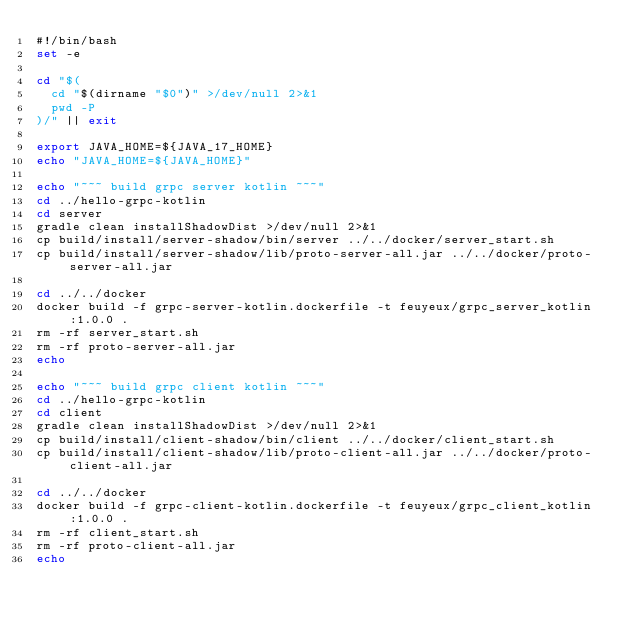Convert code to text. <code><loc_0><loc_0><loc_500><loc_500><_Bash_>#!/bin/bash
set -e

cd "$(
  cd "$(dirname "$0")" >/dev/null 2>&1
  pwd -P
)/" || exit

export JAVA_HOME=${JAVA_17_HOME}
echo "JAVA_HOME=${JAVA_HOME}"

echo "~~~ build grpc server kotlin ~~~"
cd ../hello-grpc-kotlin
cd server
gradle clean installShadowDist >/dev/null 2>&1
cp build/install/server-shadow/bin/server ../../docker/server_start.sh
cp build/install/server-shadow/lib/proto-server-all.jar ../../docker/proto-server-all.jar

cd ../../docker
docker build -f grpc-server-kotlin.dockerfile -t feuyeux/grpc_server_kotlin:1.0.0 .
rm -rf server_start.sh
rm -rf proto-server-all.jar
echo

echo "~~~ build grpc client kotlin ~~~"
cd ../hello-grpc-kotlin
cd client
gradle clean installShadowDist >/dev/null 2>&1
cp build/install/client-shadow/bin/client ../../docker/client_start.sh
cp build/install/client-shadow/lib/proto-client-all.jar ../../docker/proto-client-all.jar

cd ../../docker
docker build -f grpc-client-kotlin.dockerfile -t feuyeux/grpc_client_kotlin:1.0.0 .
rm -rf client_start.sh
rm -rf proto-client-all.jar
echo
</code> 